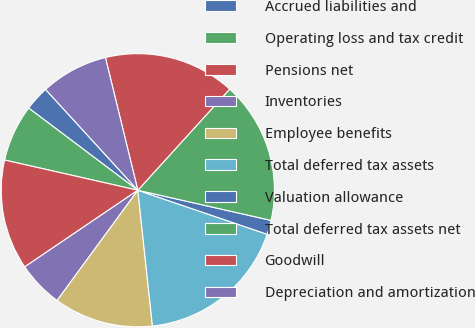<chart> <loc_0><loc_0><loc_500><loc_500><pie_chart><fcel>Accrued liabilities and<fcel>Operating loss and tax credit<fcel>Pensions net<fcel>Inventories<fcel>Employee benefits<fcel>Total deferred tax assets<fcel>Valuation allowance<fcel>Total deferred tax assets net<fcel>Goodwill<fcel>Depreciation and amortization<nl><fcel>2.94%<fcel>6.72%<fcel>13.03%<fcel>5.46%<fcel>11.77%<fcel>18.07%<fcel>1.68%<fcel>16.81%<fcel>15.55%<fcel>7.98%<nl></chart> 